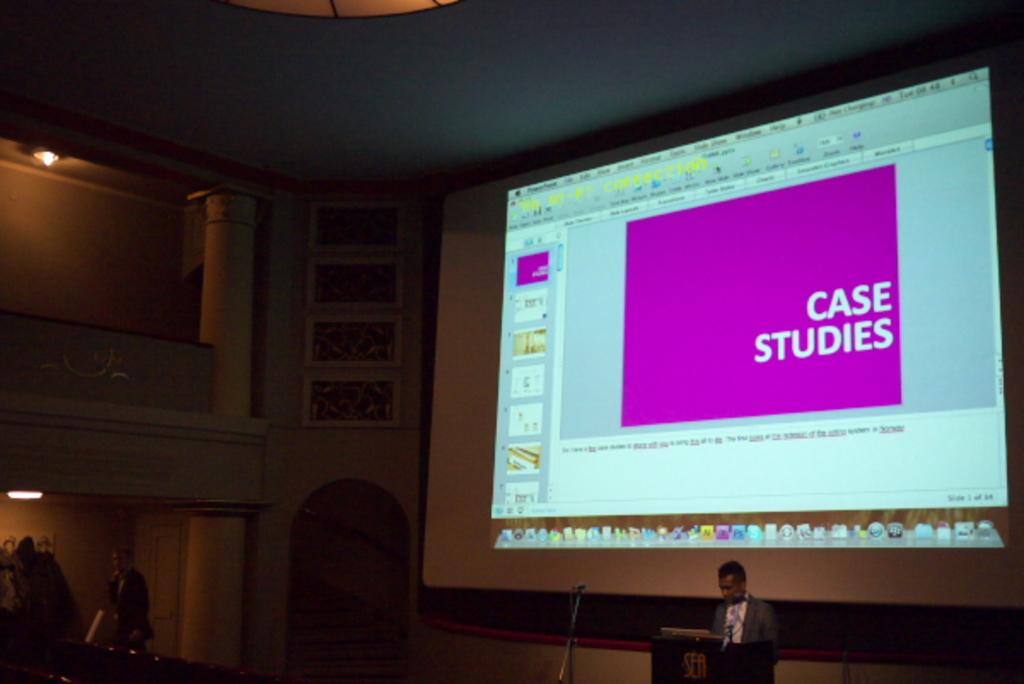Provide a one-sentence caption for the provided image. A computer monitor with the words Case Studies shown on the screen. 